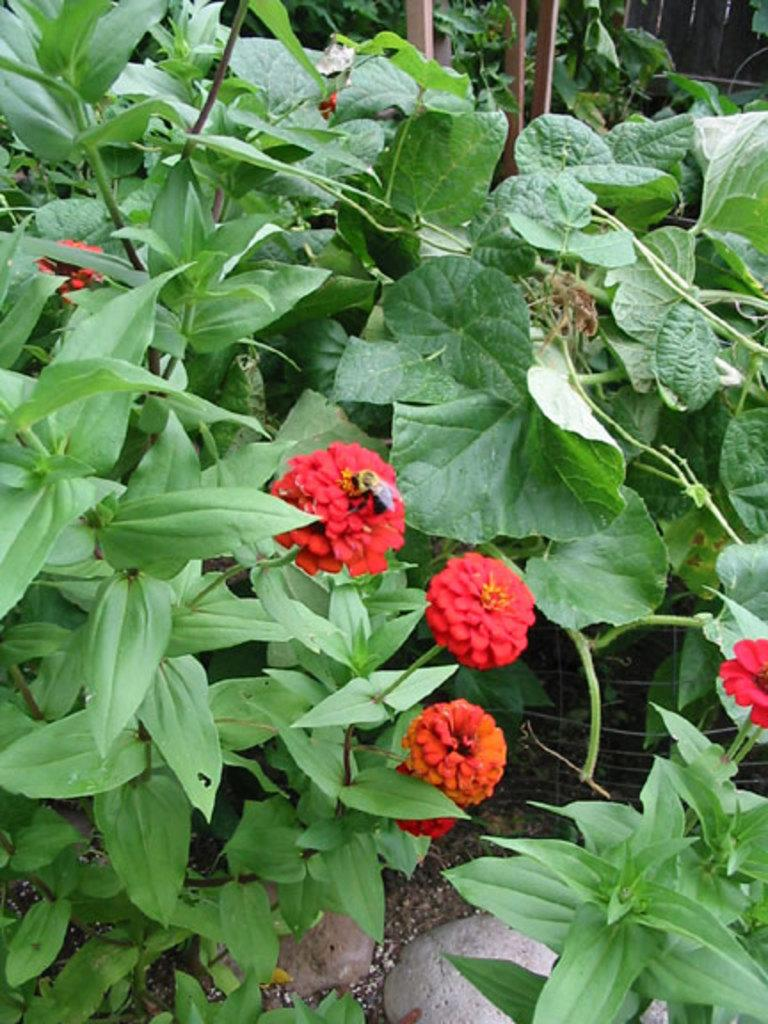What type of plants can be seen in the image? There are plants with flowers in the image. What can be found on the ground in the image? There are stones on the ground in the image. What type of barrier is present in the image? There are fences in the image. What other objects can be seen in the image? There are sticks in the image. What color is the crayon used to draw the history of the van in the image? There is no crayon, van, or history depicted in the image; it features plants, stones, fences, and sticks. 